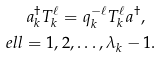<formula> <loc_0><loc_0><loc_500><loc_500>a _ { k } ^ { \dagger } T _ { k } ^ { \ell } = q _ { k } ^ { - \ell } T _ { k } ^ { \ell } a ^ { \dagger } , \ \\ e l l = 1 , 2 , \dots , \lambda _ { k } - 1 .</formula> 